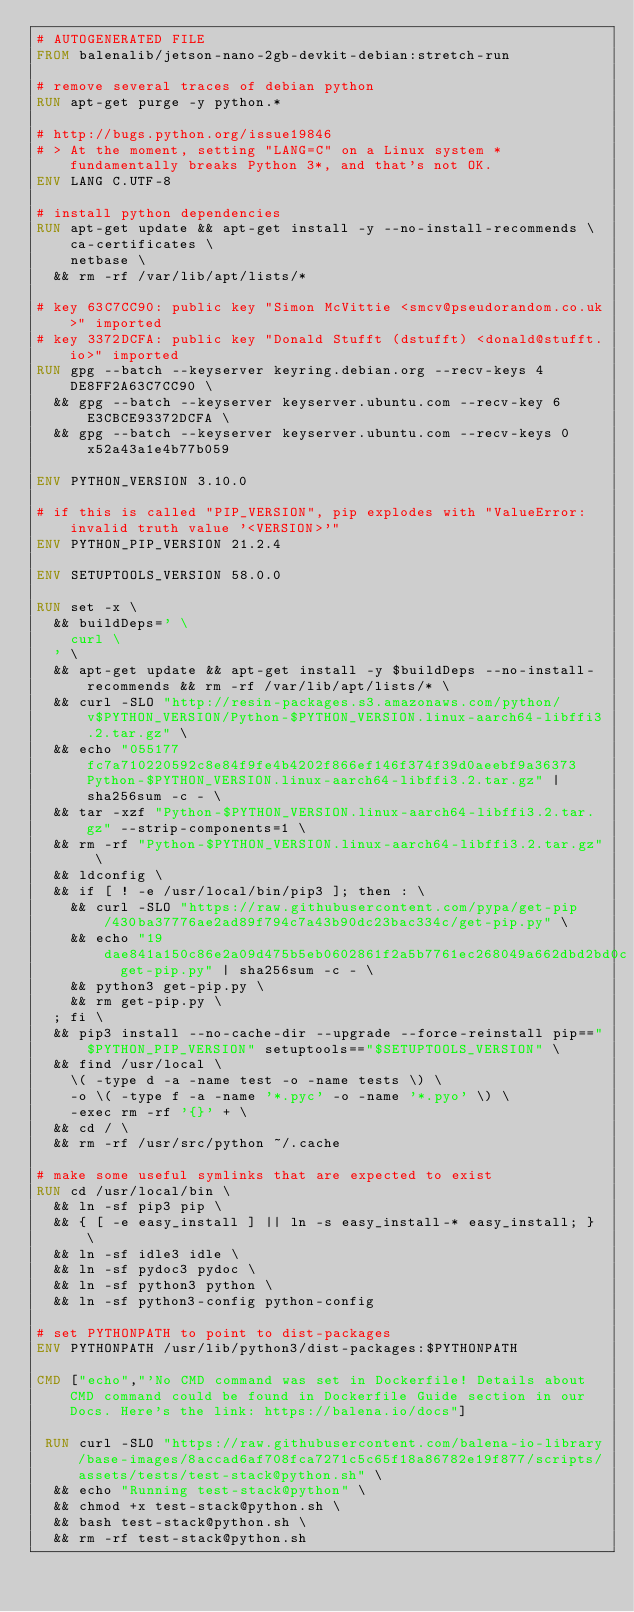<code> <loc_0><loc_0><loc_500><loc_500><_Dockerfile_># AUTOGENERATED FILE
FROM balenalib/jetson-nano-2gb-devkit-debian:stretch-run

# remove several traces of debian python
RUN apt-get purge -y python.*

# http://bugs.python.org/issue19846
# > At the moment, setting "LANG=C" on a Linux system *fundamentally breaks Python 3*, and that's not OK.
ENV LANG C.UTF-8

# install python dependencies
RUN apt-get update && apt-get install -y --no-install-recommends \
		ca-certificates \
		netbase \
	&& rm -rf /var/lib/apt/lists/*

# key 63C7CC90: public key "Simon McVittie <smcv@pseudorandom.co.uk>" imported
# key 3372DCFA: public key "Donald Stufft (dstufft) <donald@stufft.io>" imported
RUN gpg --batch --keyserver keyring.debian.org --recv-keys 4DE8FF2A63C7CC90 \
	&& gpg --batch --keyserver keyserver.ubuntu.com --recv-key 6E3CBCE93372DCFA \
	&& gpg --batch --keyserver keyserver.ubuntu.com --recv-keys 0x52a43a1e4b77b059

ENV PYTHON_VERSION 3.10.0

# if this is called "PIP_VERSION", pip explodes with "ValueError: invalid truth value '<VERSION>'"
ENV PYTHON_PIP_VERSION 21.2.4

ENV SETUPTOOLS_VERSION 58.0.0

RUN set -x \
	&& buildDeps=' \
		curl \
	' \
	&& apt-get update && apt-get install -y $buildDeps --no-install-recommends && rm -rf /var/lib/apt/lists/* \
	&& curl -SLO "http://resin-packages.s3.amazonaws.com/python/v$PYTHON_VERSION/Python-$PYTHON_VERSION.linux-aarch64-libffi3.2.tar.gz" \
	&& echo "055177fc7a710220592c8e84f9fe4b4202f866ef146f374f39d0aeebf9a36373  Python-$PYTHON_VERSION.linux-aarch64-libffi3.2.tar.gz" | sha256sum -c - \
	&& tar -xzf "Python-$PYTHON_VERSION.linux-aarch64-libffi3.2.tar.gz" --strip-components=1 \
	&& rm -rf "Python-$PYTHON_VERSION.linux-aarch64-libffi3.2.tar.gz" \
	&& ldconfig \
	&& if [ ! -e /usr/local/bin/pip3 ]; then : \
		&& curl -SLO "https://raw.githubusercontent.com/pypa/get-pip/430ba37776ae2ad89f794c7a43b90dc23bac334c/get-pip.py" \
		&& echo "19dae841a150c86e2a09d475b5eb0602861f2a5b7761ec268049a662dbd2bd0c  get-pip.py" | sha256sum -c - \
		&& python3 get-pip.py \
		&& rm get-pip.py \
	; fi \
	&& pip3 install --no-cache-dir --upgrade --force-reinstall pip=="$PYTHON_PIP_VERSION" setuptools=="$SETUPTOOLS_VERSION" \
	&& find /usr/local \
		\( -type d -a -name test -o -name tests \) \
		-o \( -type f -a -name '*.pyc' -o -name '*.pyo' \) \
		-exec rm -rf '{}' + \
	&& cd / \
	&& rm -rf /usr/src/python ~/.cache

# make some useful symlinks that are expected to exist
RUN cd /usr/local/bin \
	&& ln -sf pip3 pip \
	&& { [ -e easy_install ] || ln -s easy_install-* easy_install; } \
	&& ln -sf idle3 idle \
	&& ln -sf pydoc3 pydoc \
	&& ln -sf python3 python \
	&& ln -sf python3-config python-config

# set PYTHONPATH to point to dist-packages
ENV PYTHONPATH /usr/lib/python3/dist-packages:$PYTHONPATH

CMD ["echo","'No CMD command was set in Dockerfile! Details about CMD command could be found in Dockerfile Guide section in our Docs. Here's the link: https://balena.io/docs"]

 RUN curl -SLO "https://raw.githubusercontent.com/balena-io-library/base-images/8accad6af708fca7271c5c65f18a86782e19f877/scripts/assets/tests/test-stack@python.sh" \
  && echo "Running test-stack@python" \
  && chmod +x test-stack@python.sh \
  && bash test-stack@python.sh \
  && rm -rf test-stack@python.sh 
</code> 